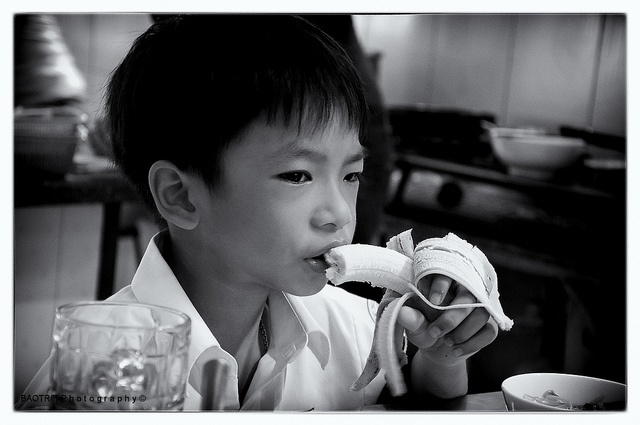Describe the objects in this image and their specific colors. I can see people in white, black, gray, darkgray, and lightgray tones, cup in white, darkgray, gray, lightgray, and black tones, banana in white, lightgray, darkgray, gray, and black tones, bowl in white, gray, lightgray, black, and darkgray tones, and bowl in white, gray, and black tones in this image. 